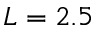<formula> <loc_0><loc_0><loc_500><loc_500>L = 2 . 5</formula> 